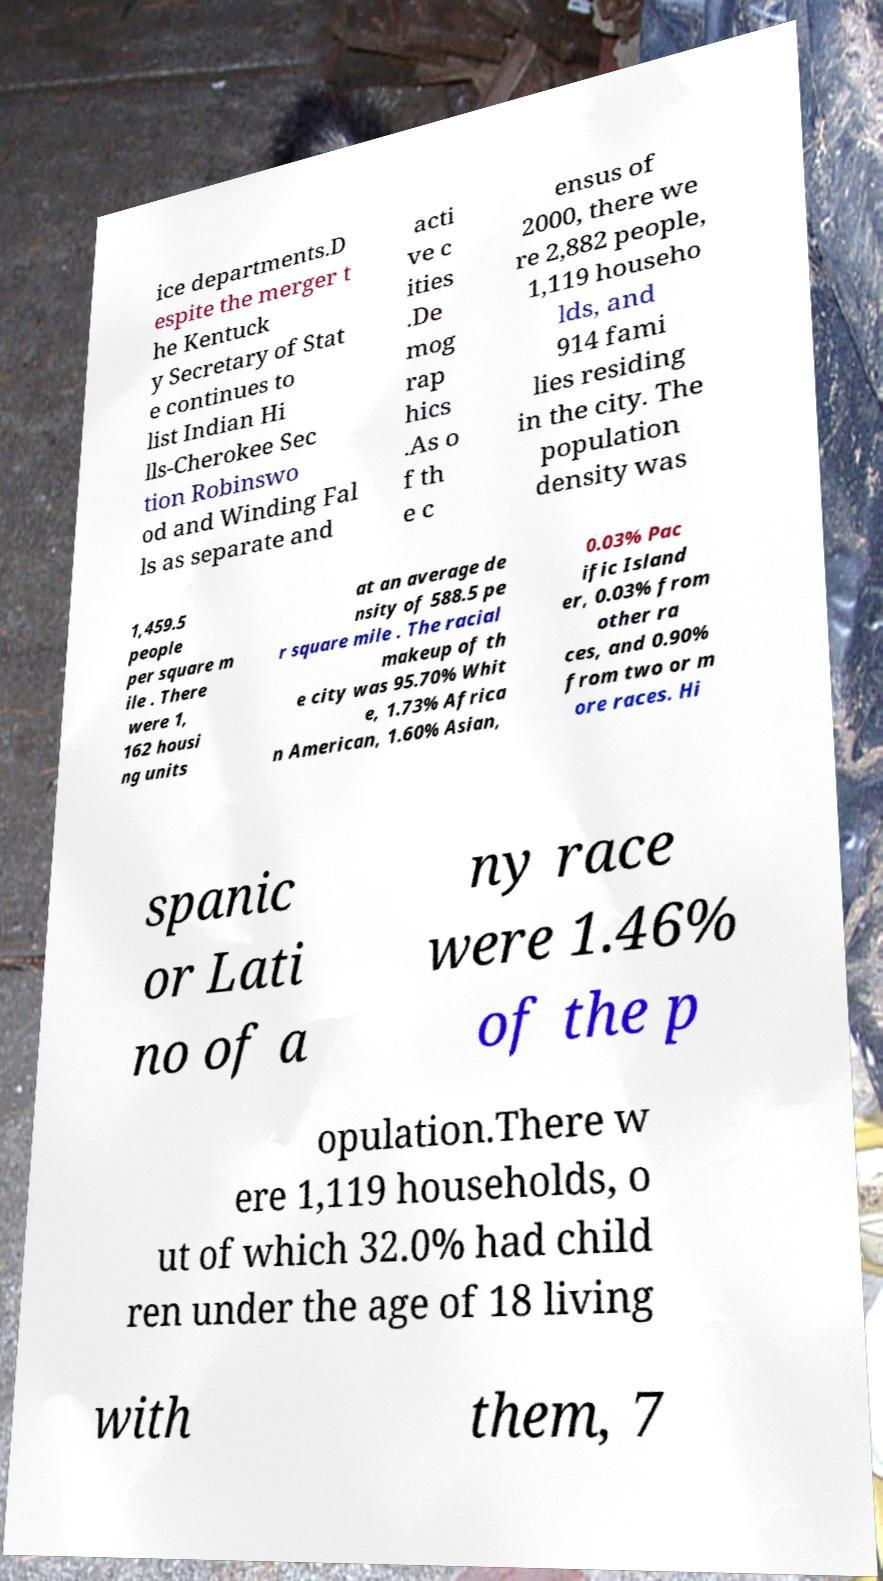Can you read and provide the text displayed in the image?This photo seems to have some interesting text. Can you extract and type it out for me? ice departments.D espite the merger t he Kentuck y Secretary of Stat e continues to list Indian Hi lls-Cherokee Sec tion Robinswo od and Winding Fal ls as separate and acti ve c ities .De mog rap hics .As o f th e c ensus of 2000, there we re 2,882 people, 1,119 househo lds, and 914 fami lies residing in the city. The population density was 1,459.5 people per square m ile . There were 1, 162 housi ng units at an average de nsity of 588.5 pe r square mile . The racial makeup of th e city was 95.70% Whit e, 1.73% Africa n American, 1.60% Asian, 0.03% Pac ific Island er, 0.03% from other ra ces, and 0.90% from two or m ore races. Hi spanic or Lati no of a ny race were 1.46% of the p opulation.There w ere 1,119 households, o ut of which 32.0% had child ren under the age of 18 living with them, 7 